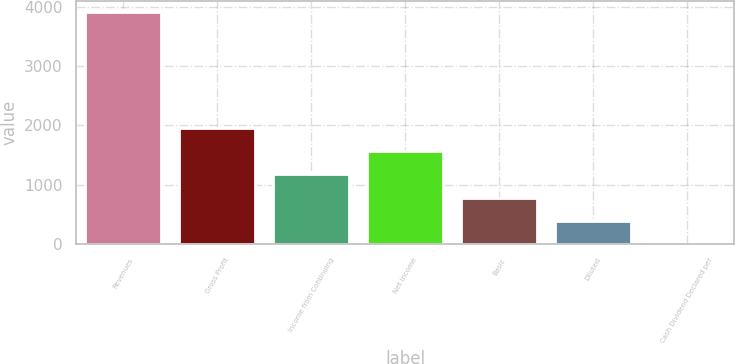<chart> <loc_0><loc_0><loc_500><loc_500><bar_chart><fcel>Revenues<fcel>Gross Profit<fcel>Income from Continuing<fcel>Net Income<fcel>Basic<fcel>Diluted<fcel>Cash Dividend Declared per<nl><fcel>3903.5<fcel>1951.84<fcel>1171.16<fcel>1561.5<fcel>780.83<fcel>390.49<fcel>0.15<nl></chart> 